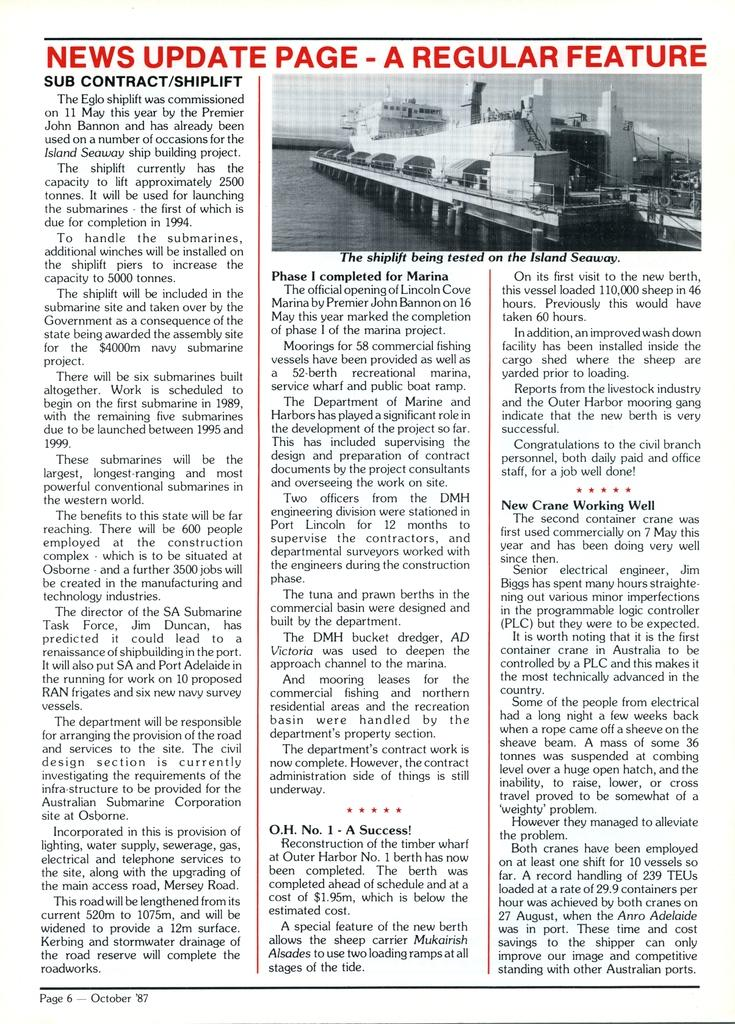<image>
Provide a brief description of the given image. a news update page that has many words on it 